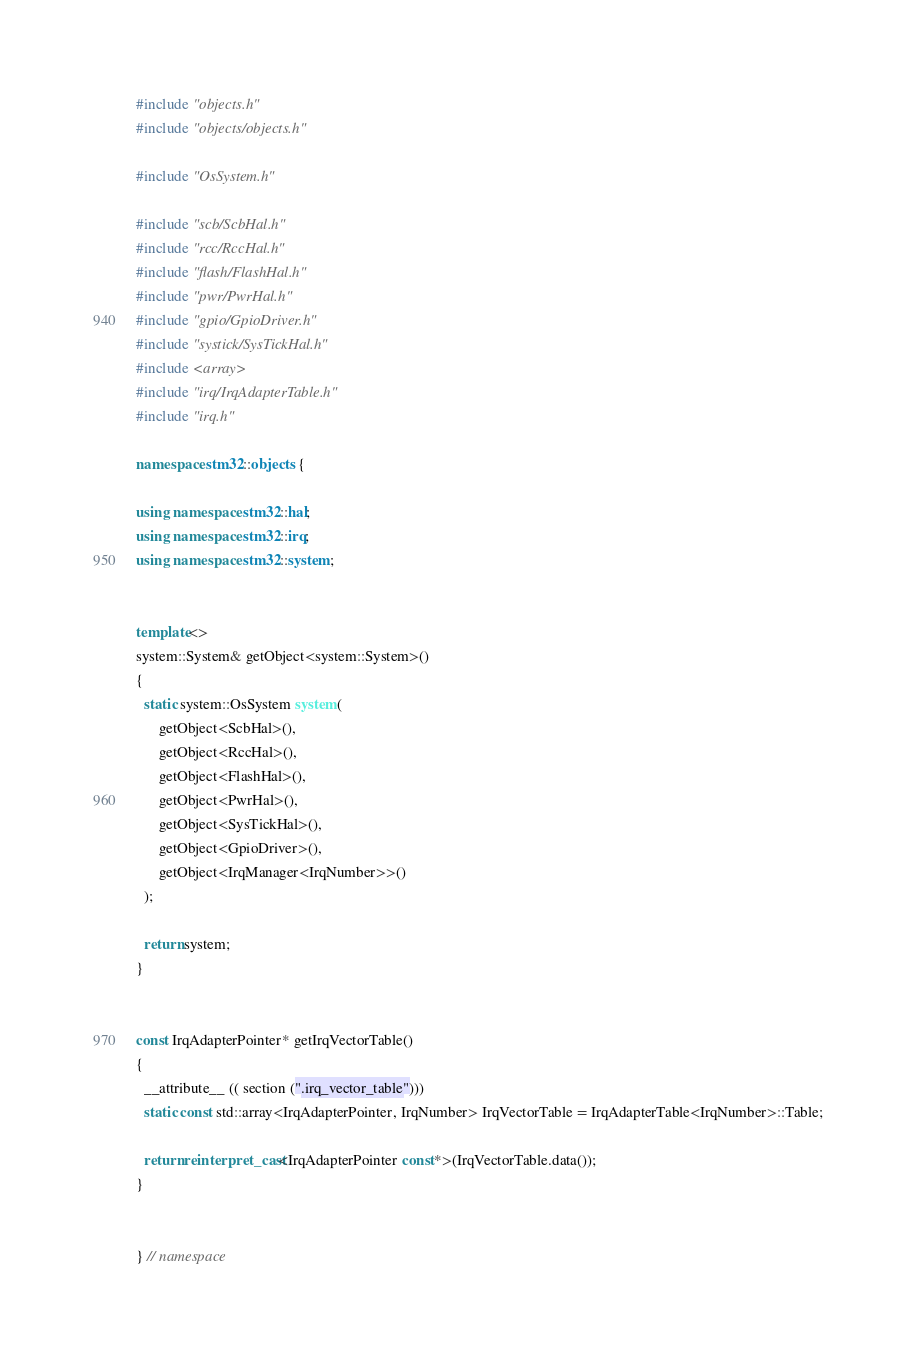<code> <loc_0><loc_0><loc_500><loc_500><_C++_>#include "objects.h"
#include "objects/objects.h"

#include "OsSystem.h"

#include "scb/ScbHal.h"
#include "rcc/RccHal.h"
#include "flash/FlashHal.h"
#include "pwr/PwrHal.h"
#include "gpio/GpioDriver.h"
#include "systick/SysTickHal.h"
#include <array>
#include "irq/IrqAdapterTable.h"
#include "irq.h"

namespace stm32::objects {

using namespace stm32::hal;
using namespace stm32::irq;
using namespace stm32::system;


template<>
system::System& getObject<system::System>()
{
  static system::OsSystem system(
      getObject<ScbHal>(),
      getObject<RccHal>(),
      getObject<FlashHal>(),
      getObject<PwrHal>(),
      getObject<SysTickHal>(),
      getObject<GpioDriver>(),
      getObject<IrqManager<IrqNumber>>()
  );

  return system;
}


const IrqAdapterPointer* getIrqVectorTable()
{
  __attribute__ (( section (".irq_vector_table")))
  static const std::array<IrqAdapterPointer, IrqNumber> IrqVectorTable = IrqAdapterTable<IrqNumber>::Table;

  return reinterpret_cast<IrqAdapterPointer const*>(IrqVectorTable.data());
}


} // namespace
</code> 